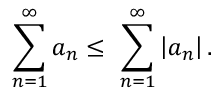Convert formula to latex. <formula><loc_0><loc_0><loc_500><loc_500>\sum _ { n = 1 } ^ { \infty } a _ { n } \leq \ \sum _ { n = 1 } ^ { \infty } \left | a _ { n } \right | .</formula> 